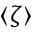Convert formula to latex. <formula><loc_0><loc_0><loc_500><loc_500>\langle \zeta \rangle</formula> 